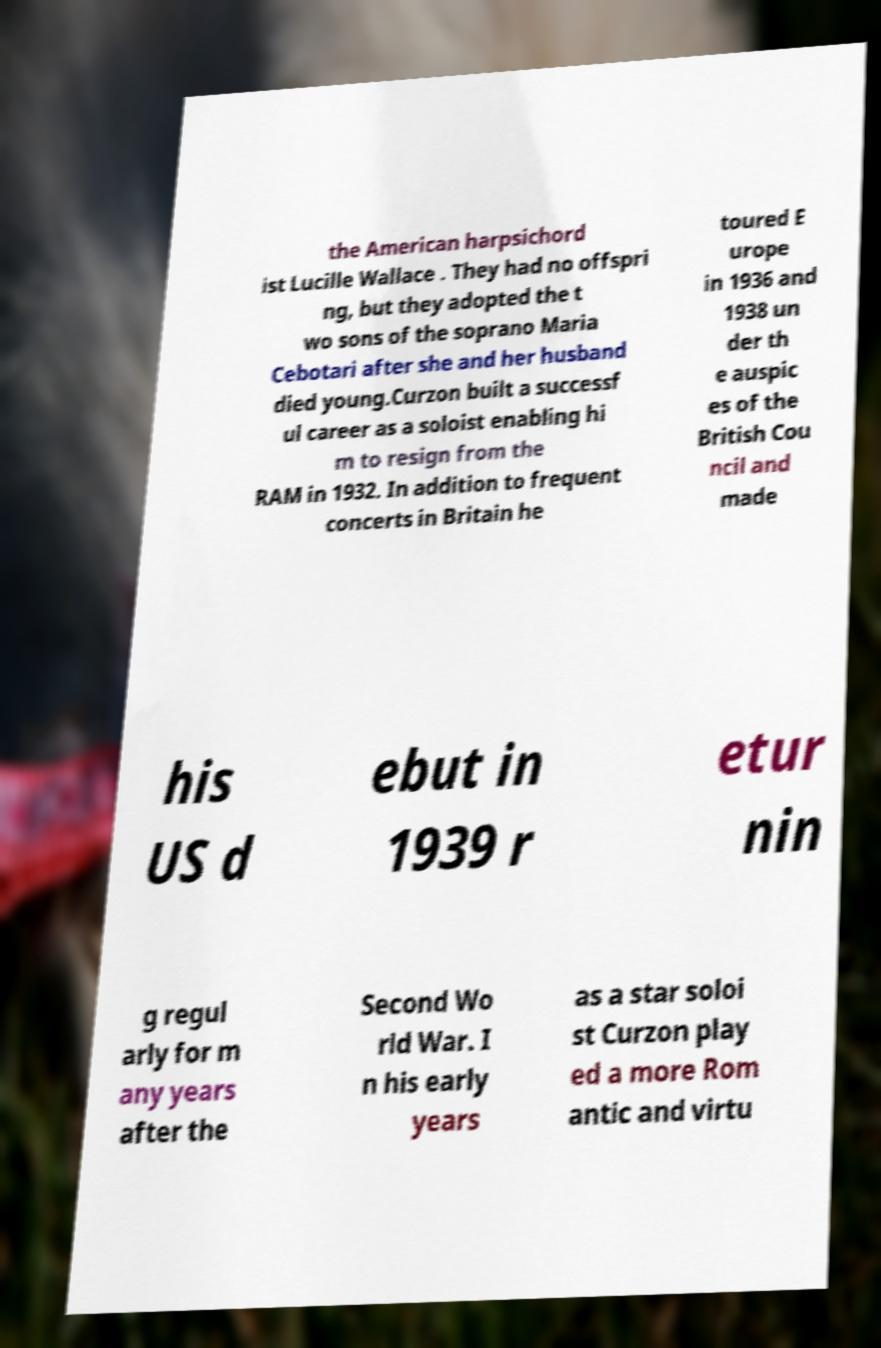Could you assist in decoding the text presented in this image and type it out clearly? the American harpsichord ist Lucille Wallace . They had no offspri ng, but they adopted the t wo sons of the soprano Maria Cebotari after she and her husband died young.Curzon built a successf ul career as a soloist enabling hi m to resign from the RAM in 1932. In addition to frequent concerts in Britain he toured E urope in 1936 and 1938 un der th e auspic es of the British Cou ncil and made his US d ebut in 1939 r etur nin g regul arly for m any years after the Second Wo rld War. I n his early years as a star soloi st Curzon play ed a more Rom antic and virtu 